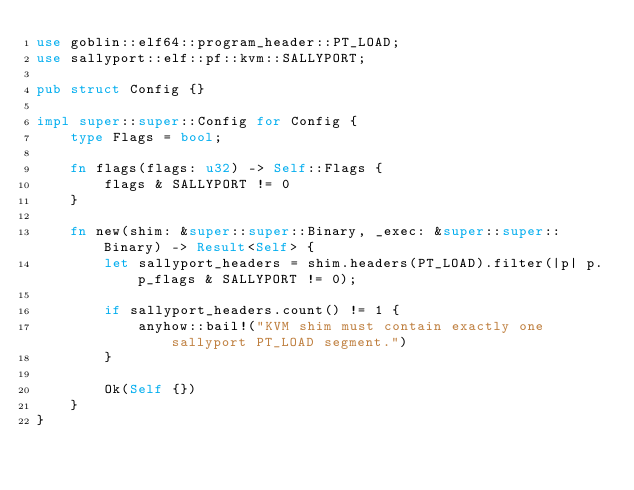<code> <loc_0><loc_0><loc_500><loc_500><_Rust_>use goblin::elf64::program_header::PT_LOAD;
use sallyport::elf::pf::kvm::SALLYPORT;

pub struct Config {}

impl super::super::Config for Config {
    type Flags = bool;

    fn flags(flags: u32) -> Self::Flags {
        flags & SALLYPORT != 0
    }

    fn new(shim: &super::super::Binary, _exec: &super::super::Binary) -> Result<Self> {
        let sallyport_headers = shim.headers(PT_LOAD).filter(|p| p.p_flags & SALLYPORT != 0);

        if sallyport_headers.count() != 1 {
            anyhow::bail!("KVM shim must contain exactly one sallyport PT_LOAD segment.")
        }

        Ok(Self {})
    }
}
</code> 